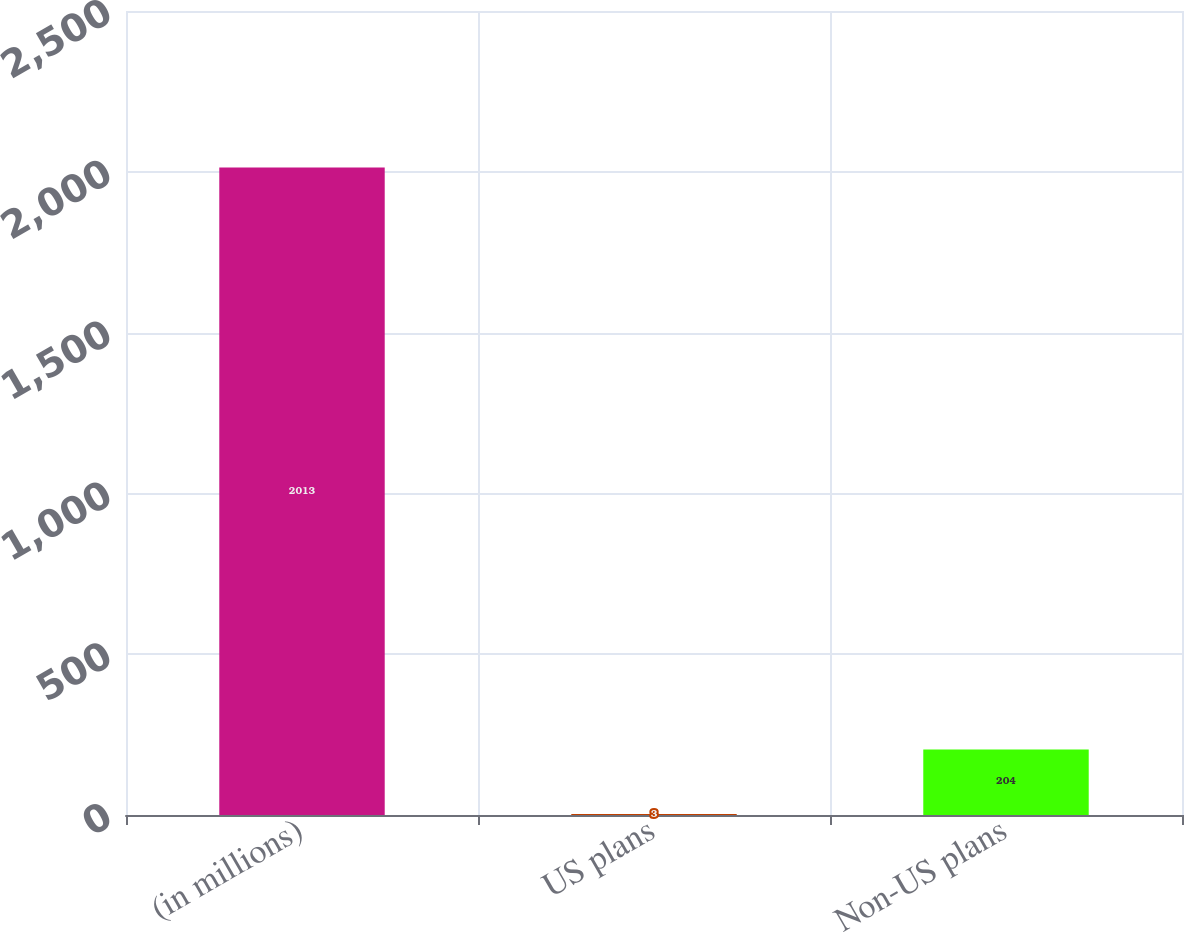Convert chart. <chart><loc_0><loc_0><loc_500><loc_500><bar_chart><fcel>(in millions)<fcel>US plans<fcel>Non-US plans<nl><fcel>2013<fcel>3<fcel>204<nl></chart> 